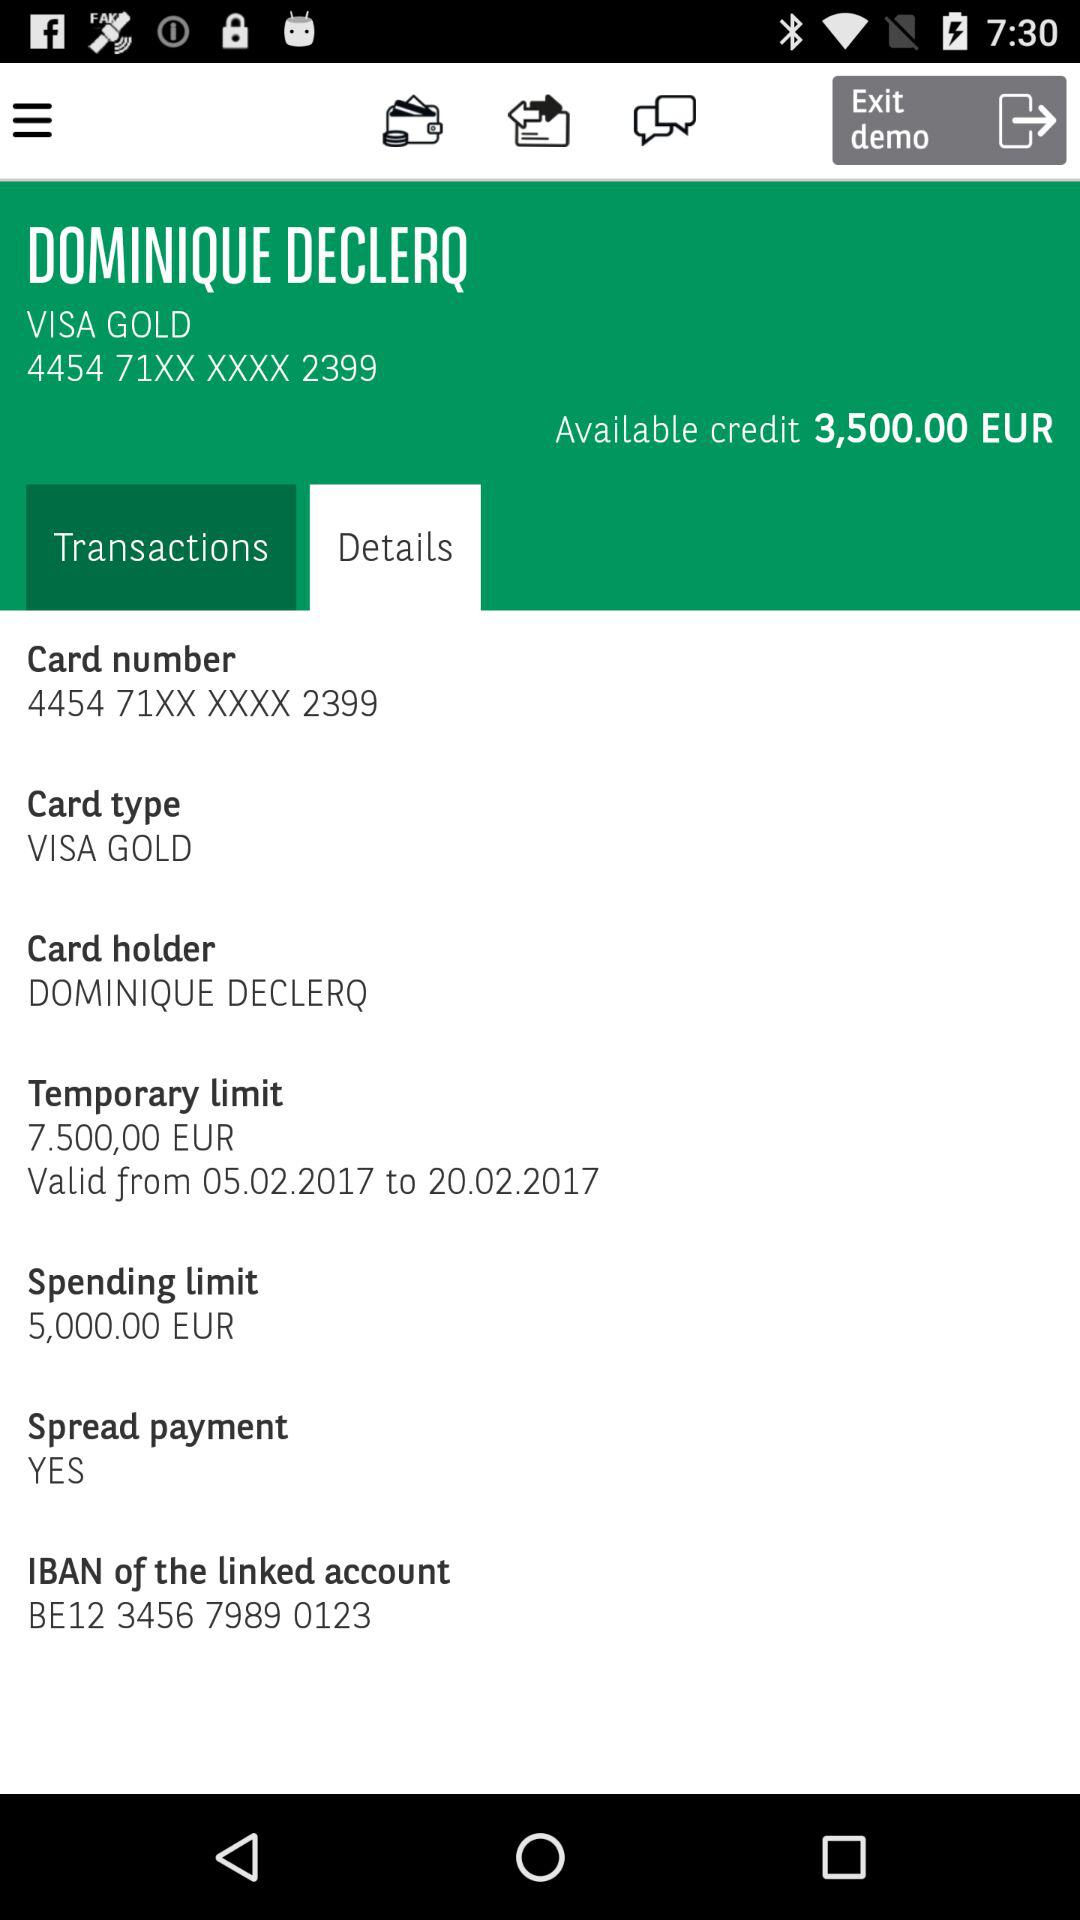What is the temporary limit of the card? The temporary limit is 7.500,00 EUR. 